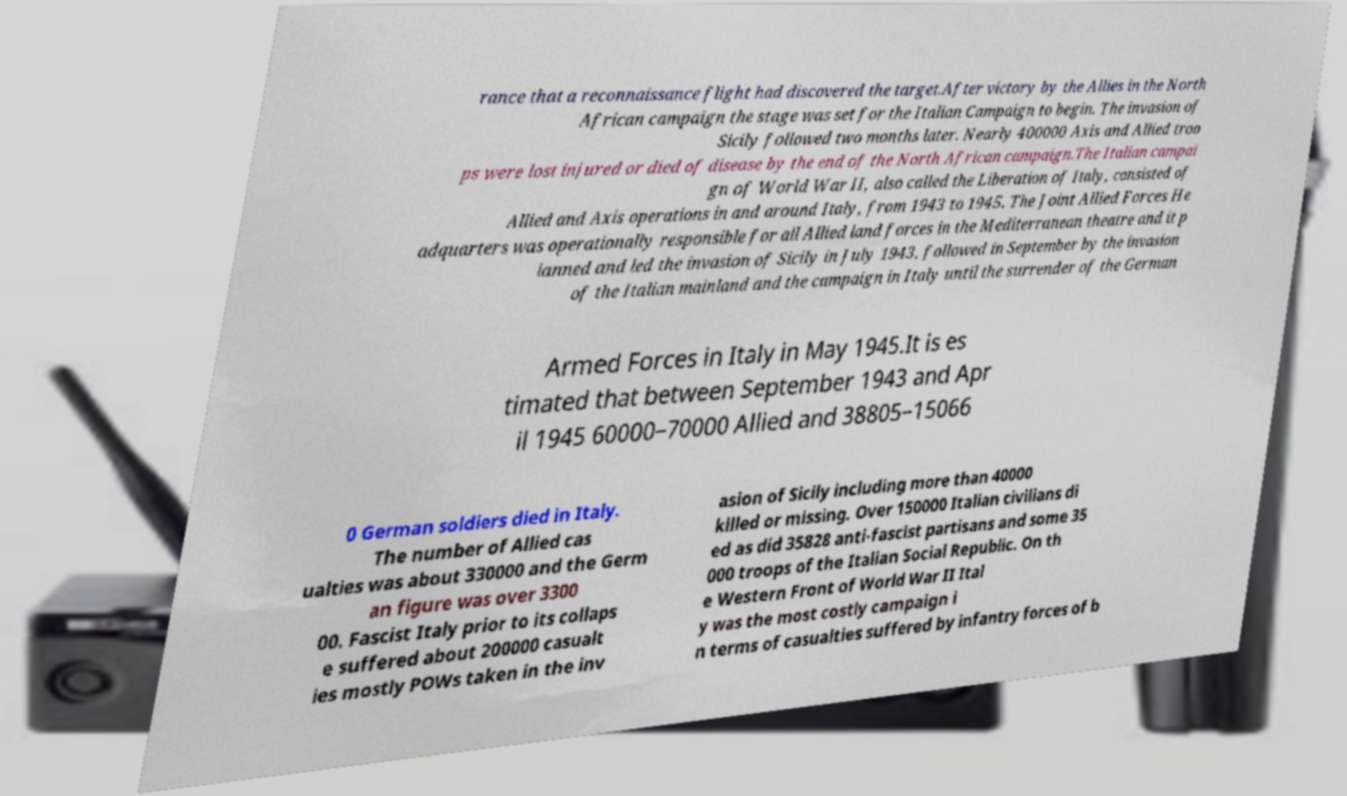For documentation purposes, I need the text within this image transcribed. Could you provide that? rance that a reconnaissance flight had discovered the target.After victory by the Allies in the North African campaign the stage was set for the Italian Campaign to begin. The invasion of Sicily followed two months later. Nearly 400000 Axis and Allied troo ps were lost injured or died of disease by the end of the North African campaign.The Italian campai gn of World War II, also called the Liberation of Italy, consisted of Allied and Axis operations in and around Italy, from 1943 to 1945. The Joint Allied Forces He adquarters was operationally responsible for all Allied land forces in the Mediterranean theatre and it p lanned and led the invasion of Sicily in July 1943, followed in September by the invasion of the Italian mainland and the campaign in Italy until the surrender of the German Armed Forces in Italy in May 1945.It is es timated that between September 1943 and Apr il 1945 60000–70000 Allied and 38805–15066 0 German soldiers died in Italy. The number of Allied cas ualties was about 330000 and the Germ an figure was over 3300 00. Fascist Italy prior to its collaps e suffered about 200000 casualt ies mostly POWs taken in the inv asion of Sicily including more than 40000 killed or missing. Over 150000 Italian civilians di ed as did 35828 anti-fascist partisans and some 35 000 troops of the Italian Social Republic. On th e Western Front of World War II Ital y was the most costly campaign i n terms of casualties suffered by infantry forces of b 